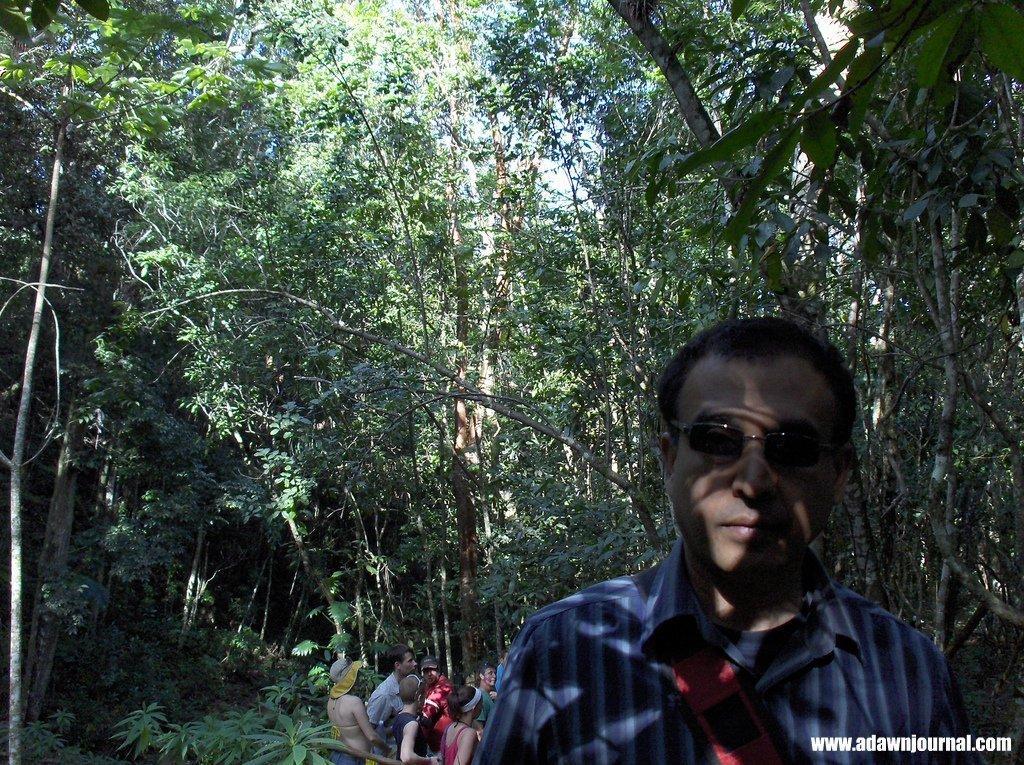How would you summarize this image in a sentence or two? In this picture we can see a man in the front, he wore spectacles, in the background there are some trees, we can see some people are standing at the bottom, at the right bottom we can see some text, there is the sky at the top of the picture. 